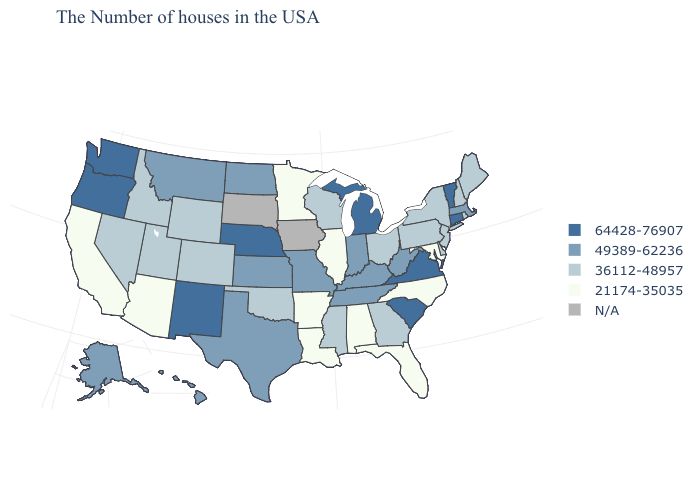Does Illinois have the lowest value in the MidWest?
Short answer required. Yes. What is the lowest value in states that border Texas?
Quick response, please. 21174-35035. Name the states that have a value in the range N/A?
Give a very brief answer. Iowa, South Dakota. What is the highest value in the USA?
Keep it brief. 64428-76907. What is the value of Delaware?
Write a very short answer. 36112-48957. Does the first symbol in the legend represent the smallest category?
Be succinct. No. What is the highest value in the MidWest ?
Give a very brief answer. 64428-76907. What is the value of Arizona?
Be succinct. 21174-35035. Does the map have missing data?
Keep it brief. Yes. What is the lowest value in the MidWest?
Concise answer only. 21174-35035. Among the states that border Wyoming , which have the lowest value?
Answer briefly. Colorado, Utah, Idaho. Name the states that have a value in the range 36112-48957?
Quick response, please. Maine, Rhode Island, New Hampshire, New York, New Jersey, Delaware, Pennsylvania, Ohio, Georgia, Wisconsin, Mississippi, Oklahoma, Wyoming, Colorado, Utah, Idaho, Nevada. What is the lowest value in the Northeast?
Concise answer only. 36112-48957. Does the map have missing data?
Answer briefly. Yes. What is the value of West Virginia?
Concise answer only. 49389-62236. 